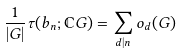<formula> <loc_0><loc_0><loc_500><loc_500>\frac { 1 } { | G | } \tau ( b _ { n } ; \mathbb { C } G ) = \sum _ { d | n } o _ { d } ( G )</formula> 